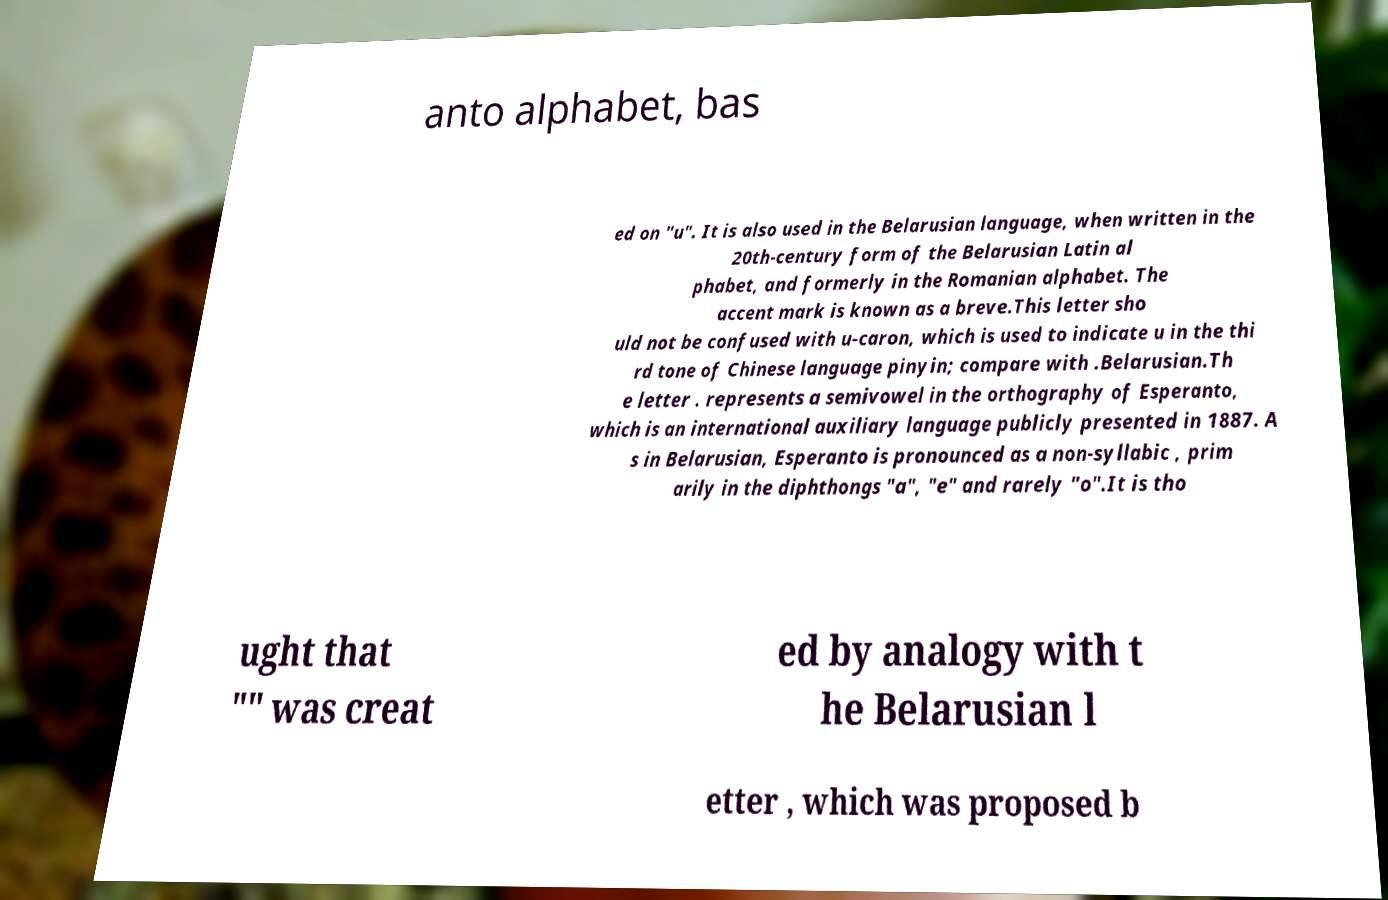Please read and relay the text visible in this image. What does it say? anto alphabet, bas ed on "u". It is also used in the Belarusian language, when written in the 20th-century form of the Belarusian Latin al phabet, and formerly in the Romanian alphabet. The accent mark is known as a breve.This letter sho uld not be confused with u-caron, which is used to indicate u in the thi rd tone of Chinese language pinyin; compare with .Belarusian.Th e letter . represents a semivowel in the orthography of Esperanto, which is an international auxiliary language publicly presented in 1887. A s in Belarusian, Esperanto is pronounced as a non-syllabic , prim arily in the diphthongs "a", "e" and rarely "o".It is tho ught that "" was creat ed by analogy with t he Belarusian l etter , which was proposed b 